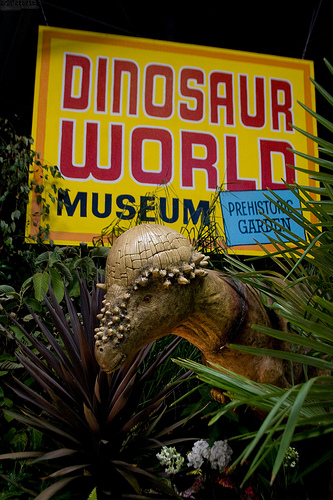<image>
Is there a dino under the sign? Yes. The dino is positioned underneath the sign, with the sign above it in the vertical space. 